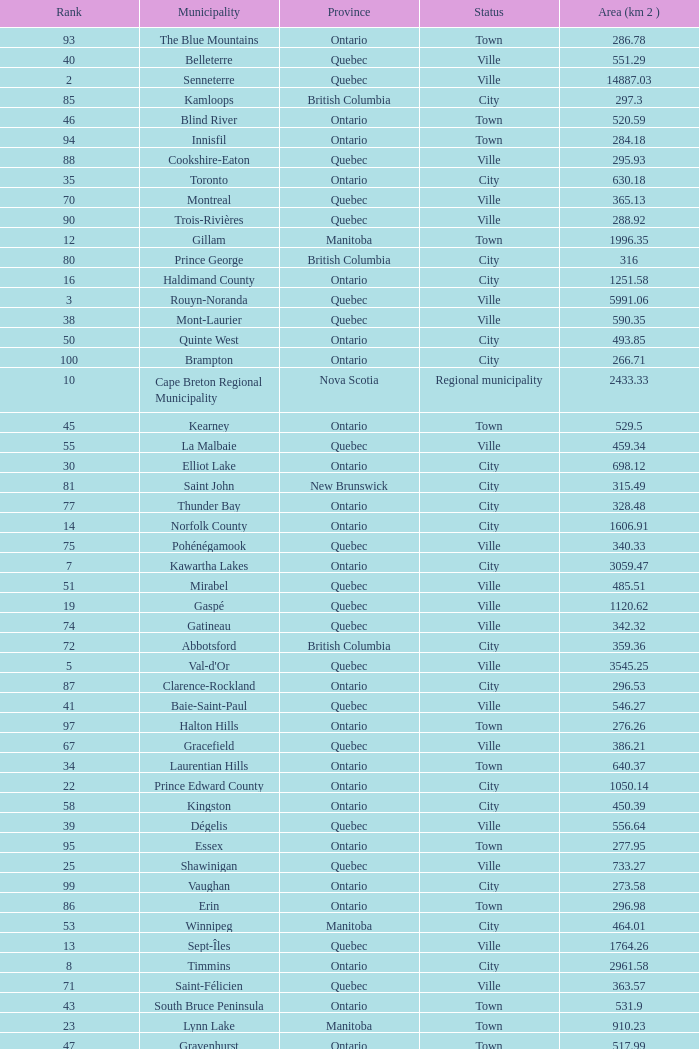What is the highest Area (KM 2) for the Province of Ontario, that has the Status of Town, a Municipality of Minto, and a Rank that's smaller than 84? None. 